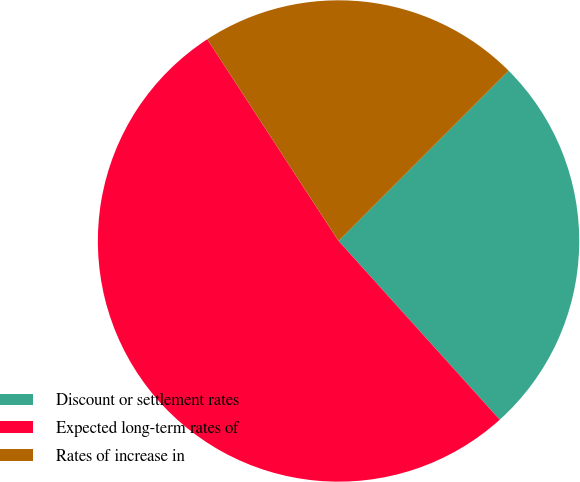Convert chart to OTSL. <chart><loc_0><loc_0><loc_500><loc_500><pie_chart><fcel>Discount or settlement rates<fcel>Expected long-term rates of<fcel>Rates of increase in<nl><fcel>25.83%<fcel>52.5%<fcel>21.67%<nl></chart> 